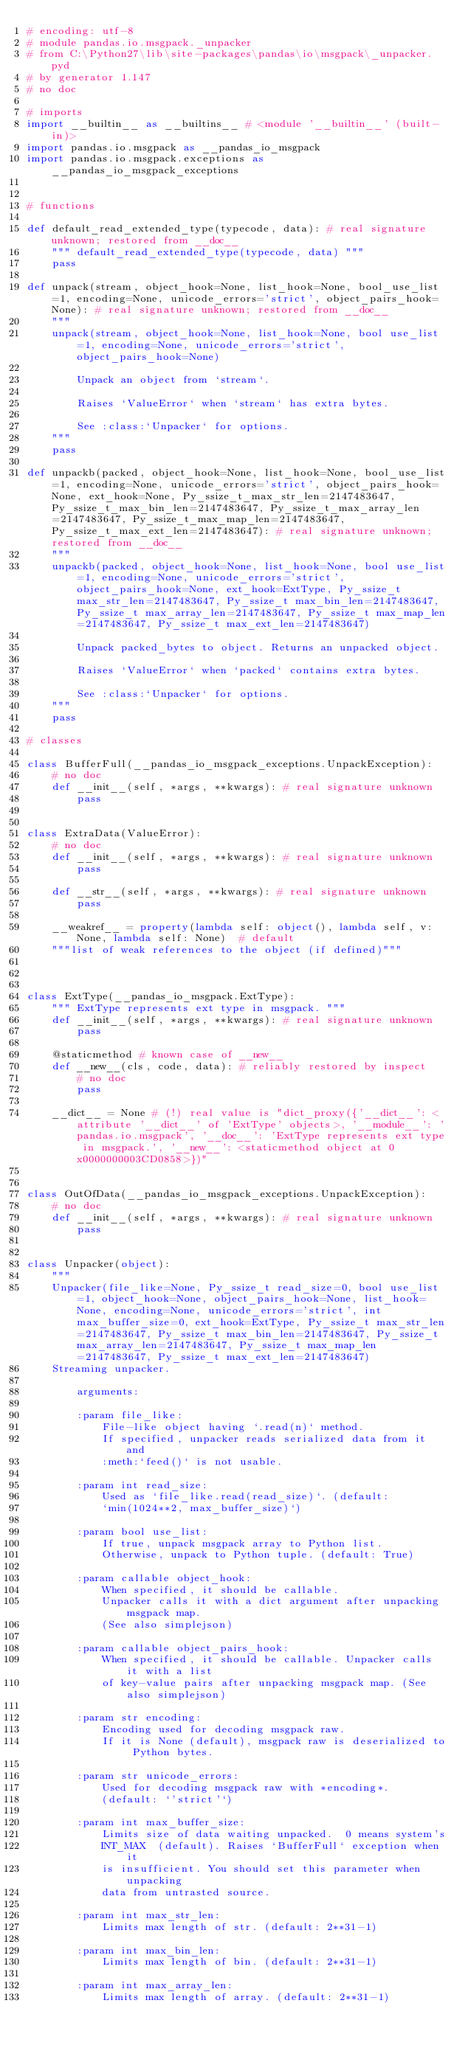<code> <loc_0><loc_0><loc_500><loc_500><_Python_># encoding: utf-8
# module pandas.io.msgpack._unpacker
# from C:\Python27\lib\site-packages\pandas\io\msgpack\_unpacker.pyd
# by generator 1.147
# no doc

# imports
import __builtin__ as __builtins__ # <module '__builtin__' (built-in)>
import pandas.io.msgpack as __pandas_io_msgpack
import pandas.io.msgpack.exceptions as __pandas_io_msgpack_exceptions


# functions

def default_read_extended_type(typecode, data): # real signature unknown; restored from __doc__
    """ default_read_extended_type(typecode, data) """
    pass

def unpack(stream, object_hook=None, list_hook=None, bool_use_list=1, encoding=None, unicode_errors='strict', object_pairs_hook=None): # real signature unknown; restored from __doc__
    """
    unpack(stream, object_hook=None, list_hook=None, bool use_list=1, encoding=None, unicode_errors='strict', object_pairs_hook=None)
    
        Unpack an object from `stream`.
    
        Raises `ValueError` when `stream` has extra bytes.
    
        See :class:`Unpacker` for options.
    """
    pass

def unpackb(packed, object_hook=None, list_hook=None, bool_use_list=1, encoding=None, unicode_errors='strict', object_pairs_hook=None, ext_hook=None, Py_ssize_t_max_str_len=2147483647, Py_ssize_t_max_bin_len=2147483647, Py_ssize_t_max_array_len=2147483647, Py_ssize_t_max_map_len=2147483647, Py_ssize_t_max_ext_len=2147483647): # real signature unknown; restored from __doc__
    """
    unpackb(packed, object_hook=None, list_hook=None, bool use_list=1, encoding=None, unicode_errors='strict', object_pairs_hook=None, ext_hook=ExtType, Py_ssize_t max_str_len=2147483647, Py_ssize_t max_bin_len=2147483647, Py_ssize_t max_array_len=2147483647, Py_ssize_t max_map_len=2147483647, Py_ssize_t max_ext_len=2147483647)
    
        Unpack packed_bytes to object. Returns an unpacked object.
    
        Raises `ValueError` when `packed` contains extra bytes.
    
        See :class:`Unpacker` for options.
    """
    pass

# classes

class BufferFull(__pandas_io_msgpack_exceptions.UnpackException):
    # no doc
    def __init__(self, *args, **kwargs): # real signature unknown
        pass


class ExtraData(ValueError):
    # no doc
    def __init__(self, *args, **kwargs): # real signature unknown
        pass

    def __str__(self, *args, **kwargs): # real signature unknown
        pass

    __weakref__ = property(lambda self: object(), lambda self, v: None, lambda self: None)  # default
    """list of weak references to the object (if defined)"""



class ExtType(__pandas_io_msgpack.ExtType):
    """ ExtType represents ext type in msgpack. """
    def __init__(self, *args, **kwargs): # real signature unknown
        pass

    @staticmethod # known case of __new__
    def __new__(cls, code, data): # reliably restored by inspect
        # no doc
        pass

    __dict__ = None # (!) real value is "dict_proxy({'__dict__': <attribute '__dict__' of 'ExtType' objects>, '__module__': 'pandas.io.msgpack', '__doc__': 'ExtType represents ext type in msgpack.', '__new__': <staticmethod object at 0x0000000003CD0858>})"


class OutOfData(__pandas_io_msgpack_exceptions.UnpackException):
    # no doc
    def __init__(self, *args, **kwargs): # real signature unknown
        pass


class Unpacker(object):
    """
    Unpacker(file_like=None, Py_ssize_t read_size=0, bool use_list=1, object_hook=None, object_pairs_hook=None, list_hook=None, encoding=None, unicode_errors='strict', int max_buffer_size=0, ext_hook=ExtType, Py_ssize_t max_str_len=2147483647, Py_ssize_t max_bin_len=2147483647, Py_ssize_t max_array_len=2147483647, Py_ssize_t max_map_len=2147483647, Py_ssize_t max_ext_len=2147483647)
    Streaming unpacker.
    
        arguments:
    
        :param file_like:
            File-like object having `.read(n)` method.
            If specified, unpacker reads serialized data from it and
            :meth:`feed()` is not usable.
    
        :param int read_size:
            Used as `file_like.read(read_size)`. (default:
            `min(1024**2, max_buffer_size)`)
    
        :param bool use_list:
            If true, unpack msgpack array to Python list.
            Otherwise, unpack to Python tuple. (default: True)
    
        :param callable object_hook:
            When specified, it should be callable.
            Unpacker calls it with a dict argument after unpacking msgpack map.
            (See also simplejson)
    
        :param callable object_pairs_hook:
            When specified, it should be callable. Unpacker calls it with a list
            of key-value pairs after unpacking msgpack map. (See also simplejson)
    
        :param str encoding:
            Encoding used for decoding msgpack raw.
            If it is None (default), msgpack raw is deserialized to Python bytes.
    
        :param str unicode_errors:
            Used for decoding msgpack raw with *encoding*.
            (default: `'strict'`)
    
        :param int max_buffer_size:
            Limits size of data waiting unpacked.  0 means system's
            INT_MAX  (default). Raises `BufferFull` exception when it
            is insufficient. You should set this parameter when unpacking
            data from untrasted source.
    
        :param int max_str_len:
            Limits max length of str. (default: 2**31-1)
    
        :param int max_bin_len:
            Limits max length of bin. (default: 2**31-1)
    
        :param int max_array_len:
            Limits max length of array. (default: 2**31-1)
    </code> 